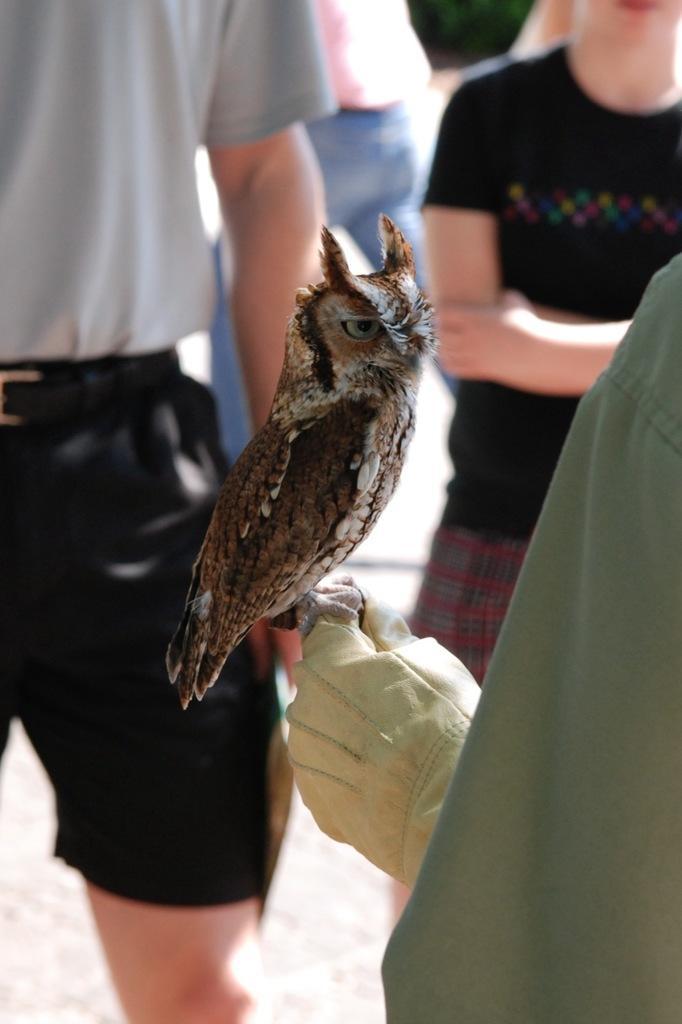Describe this image in one or two sentences. Here I can see a person wearing a glove to the hand and holding an owl. In the background a man and a woman are standing on the ground. In the background, I can see some more people. 